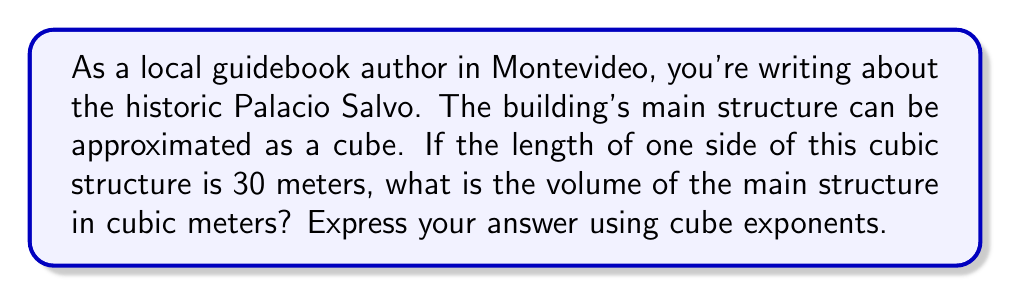Give your solution to this math problem. To solve this problem, we need to use the formula for the volume of a cube:

$$V = s^3$$

Where:
$V$ = volume
$s$ = length of one side

Given:
$s = 30$ meters

Let's substitute this into our formula:

$$V = 30^3$$

To calculate this:
1. $30^3 = 30 \times 30 \times 30$
2. $30 \times 30 = 900$
3. $900 \times 30 = 27,000$

Therefore, the volume of the main structure of Palacio Salvo can be expressed as $30^3$ or 27,000 cubic meters.
Answer: $30^3$ or 27,000 cubic meters 